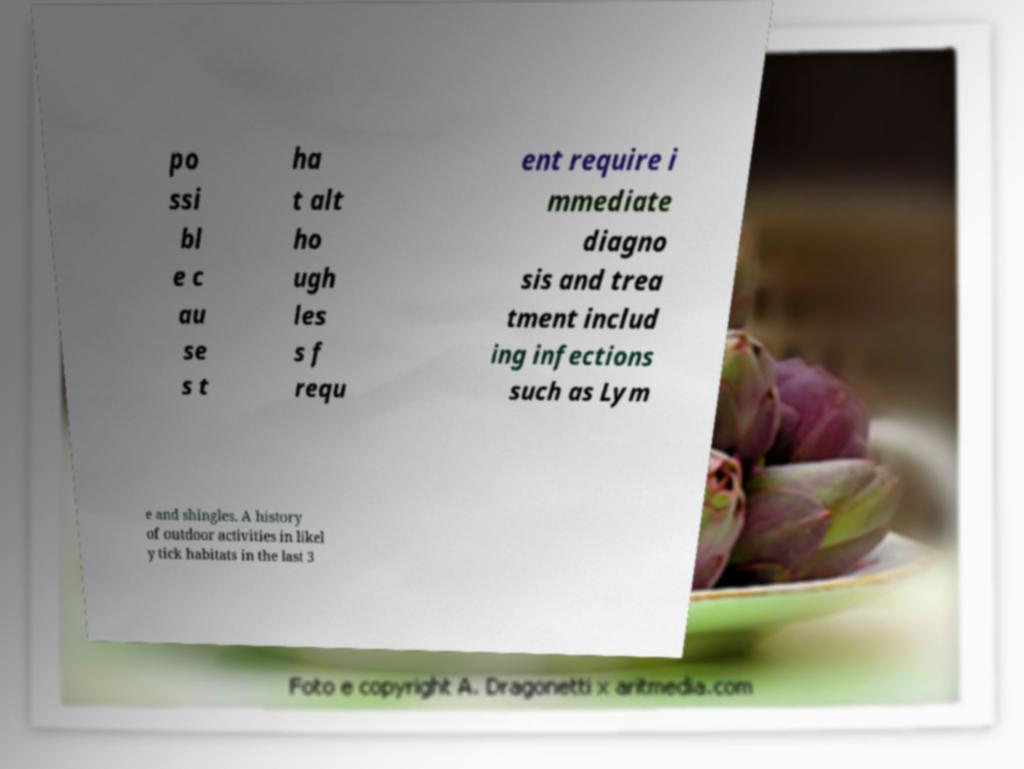Could you extract and type out the text from this image? po ssi bl e c au se s t ha t alt ho ugh les s f requ ent require i mmediate diagno sis and trea tment includ ing infections such as Lym e and shingles. A history of outdoor activities in likel y tick habitats in the last 3 